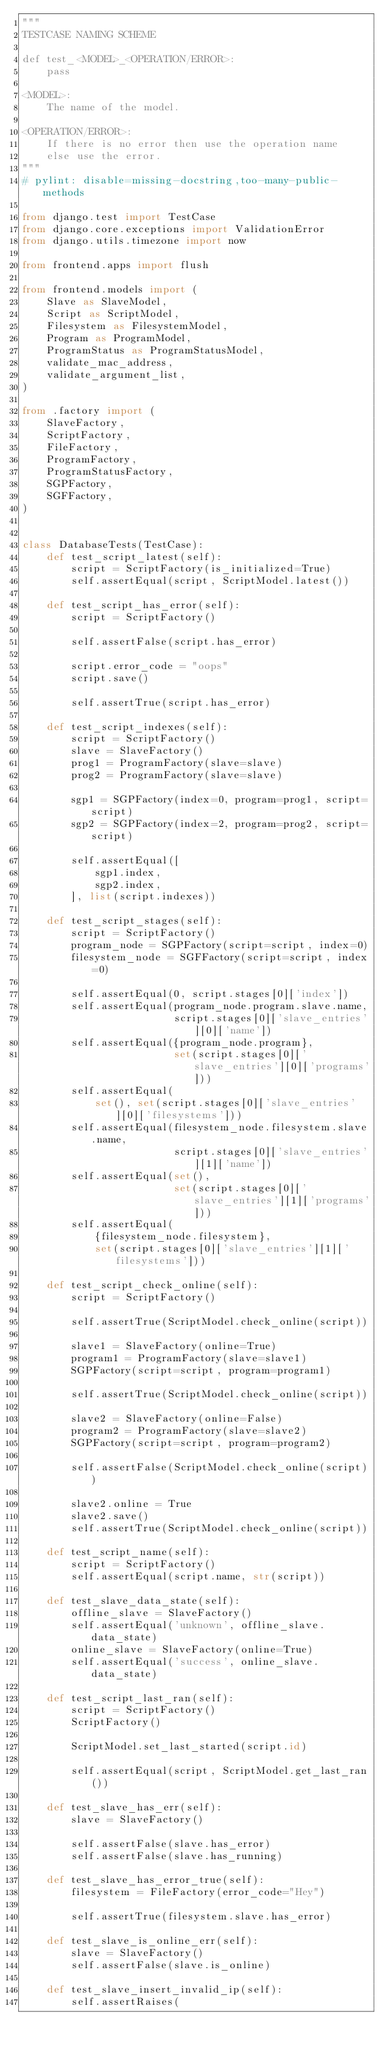Convert code to text. <code><loc_0><loc_0><loc_500><loc_500><_Python_>"""
TESTCASE NAMING SCHEME

def test_<MODEL>_<OPERATION/ERROR>:
    pass

<MODEL>:
    The name of the model.

<OPERATION/ERROR>:
    If there is no error then use the operation name
    else use the error.
"""
# pylint: disable=missing-docstring,too-many-public-methods

from django.test import TestCase
from django.core.exceptions import ValidationError
from django.utils.timezone import now

from frontend.apps import flush

from frontend.models import (
    Slave as SlaveModel,
    Script as ScriptModel,
    Filesystem as FilesystemModel,
    Program as ProgramModel,
    ProgramStatus as ProgramStatusModel,
    validate_mac_address,
    validate_argument_list,
)

from .factory import (
    SlaveFactory,
    ScriptFactory,
    FileFactory,
    ProgramFactory,
    ProgramStatusFactory,
    SGPFactory,
    SGFFactory,
)


class DatabaseTests(TestCase):
    def test_script_latest(self):
        script = ScriptFactory(is_initialized=True)
        self.assertEqual(script, ScriptModel.latest())

    def test_script_has_error(self):
        script = ScriptFactory()

        self.assertFalse(script.has_error)

        script.error_code = "oops"
        script.save()

        self.assertTrue(script.has_error)

    def test_script_indexes(self):
        script = ScriptFactory()
        slave = SlaveFactory()
        prog1 = ProgramFactory(slave=slave)
        prog2 = ProgramFactory(slave=slave)

        sgp1 = SGPFactory(index=0, program=prog1, script=script)
        sgp2 = SGPFactory(index=2, program=prog2, script=script)

        self.assertEqual([
            sgp1.index,
            sgp2.index,
        ], list(script.indexes))

    def test_script_stages(self):
        script = ScriptFactory()
        program_node = SGPFactory(script=script, index=0)
        filesystem_node = SGFFactory(script=script, index=0)

        self.assertEqual(0, script.stages[0]['index'])
        self.assertEqual(program_node.program.slave.name,
                         script.stages[0]['slave_entries'][0]['name'])
        self.assertEqual({program_node.program},
                         set(script.stages[0]['slave_entries'][0]['programs']))
        self.assertEqual(
            set(), set(script.stages[0]['slave_entries'][0]['filesystems']))
        self.assertEqual(filesystem_node.filesystem.slave.name,
                         script.stages[0]['slave_entries'][1]['name'])
        self.assertEqual(set(),
                         set(script.stages[0]['slave_entries'][1]['programs']))
        self.assertEqual(
            {filesystem_node.filesystem},
            set(script.stages[0]['slave_entries'][1]['filesystems']))

    def test_script_check_online(self):
        script = ScriptFactory()

        self.assertTrue(ScriptModel.check_online(script))

        slave1 = SlaveFactory(online=True)
        program1 = ProgramFactory(slave=slave1)
        SGPFactory(script=script, program=program1)

        self.assertTrue(ScriptModel.check_online(script))

        slave2 = SlaveFactory(online=False)
        program2 = ProgramFactory(slave=slave2)
        SGPFactory(script=script, program=program2)

        self.assertFalse(ScriptModel.check_online(script))

        slave2.online = True
        slave2.save()
        self.assertTrue(ScriptModel.check_online(script))

    def test_script_name(self):
        script = ScriptFactory()
        self.assertEqual(script.name, str(script))

    def test_slave_data_state(self):
        offline_slave = SlaveFactory()
        self.assertEqual('unknown', offline_slave.data_state)
        online_slave = SlaveFactory(online=True)
        self.assertEqual('success', online_slave.data_state)

    def test_script_last_ran(self):
        script = ScriptFactory()
        ScriptFactory()

        ScriptModel.set_last_started(script.id)

        self.assertEqual(script, ScriptModel.get_last_ran())

    def test_slave_has_err(self):
        slave = SlaveFactory()

        self.assertFalse(slave.has_error)
        self.assertFalse(slave.has_running)

    def test_slave_has_error_true(self):
        filesystem = FileFactory(error_code="Hey")

        self.assertTrue(filesystem.slave.has_error)

    def test_slave_is_online_err(self):
        slave = SlaveFactory()
        self.assertFalse(slave.is_online)

    def test_slave_insert_invalid_ip(self):
        self.assertRaises(</code> 